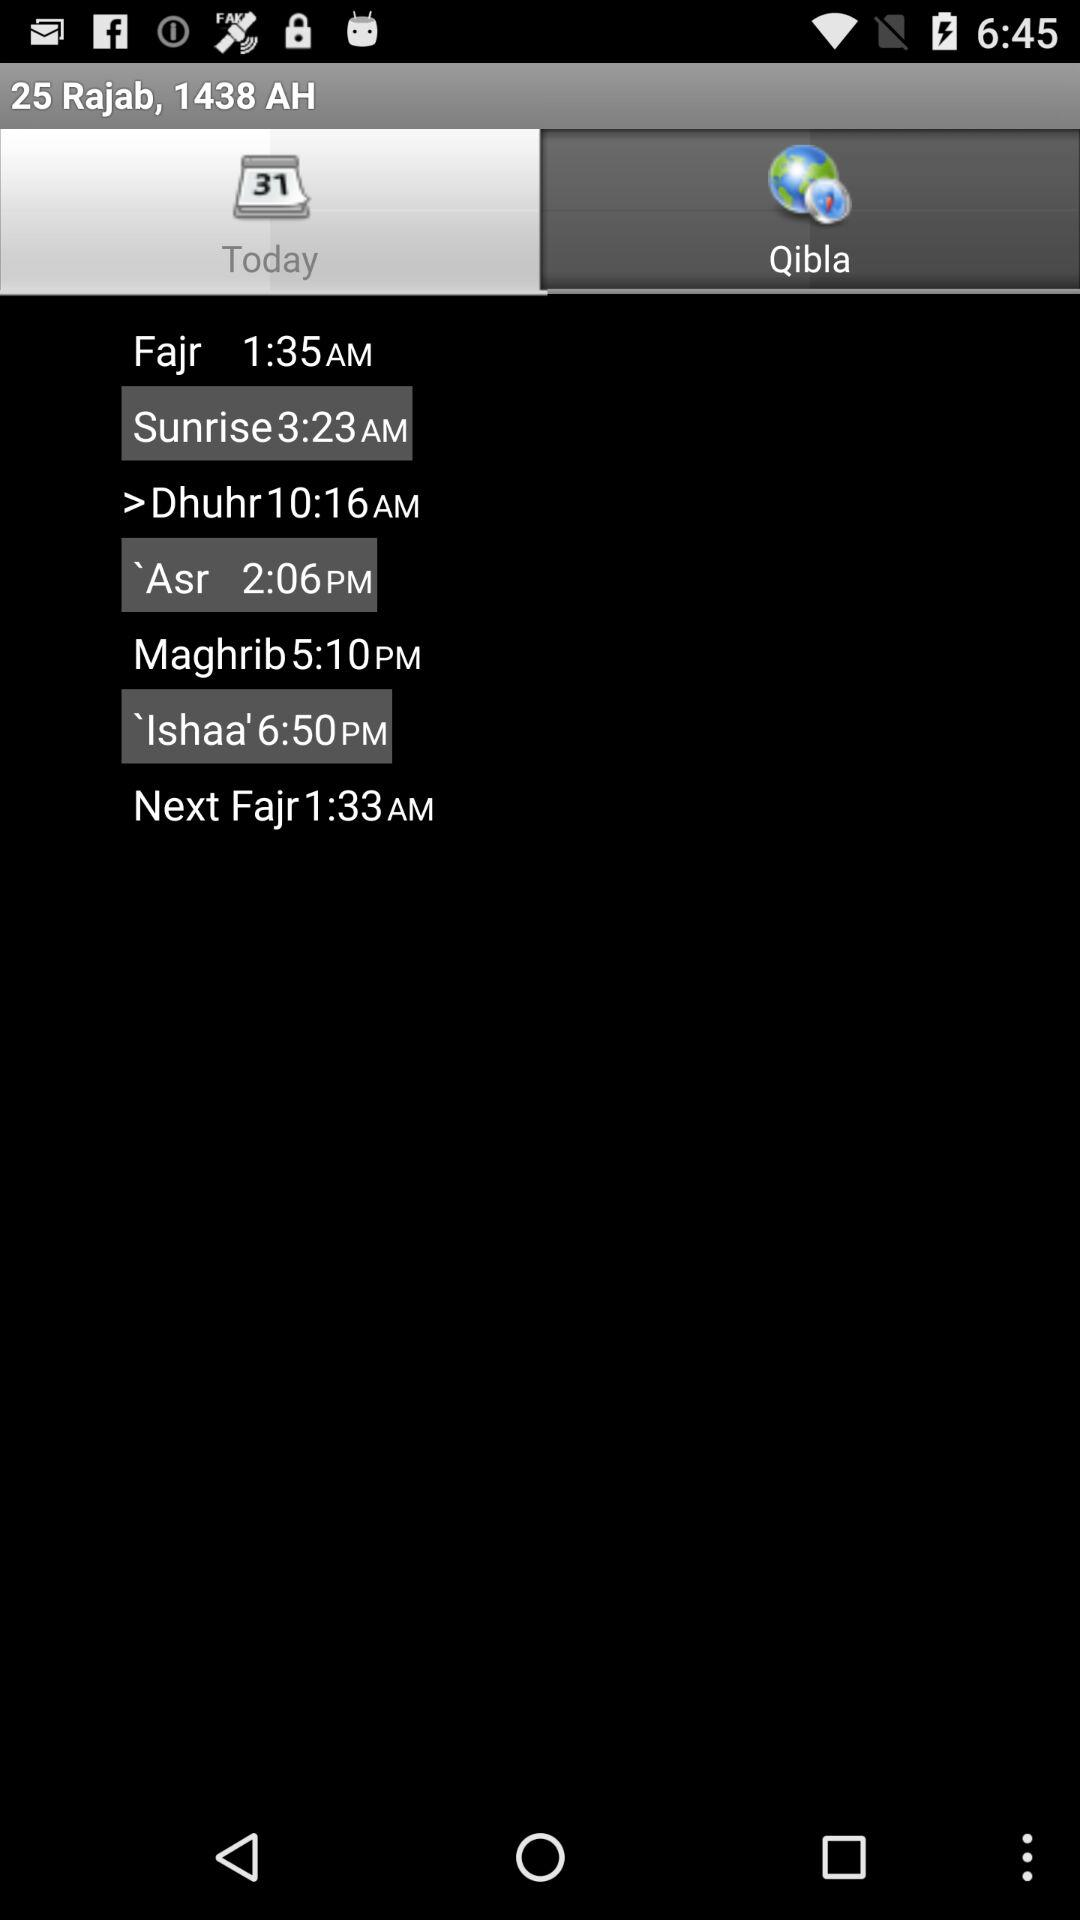Which prayer time is later, Ishaa or Maghrib?
Answer the question using a single word or phrase. Ishaa 